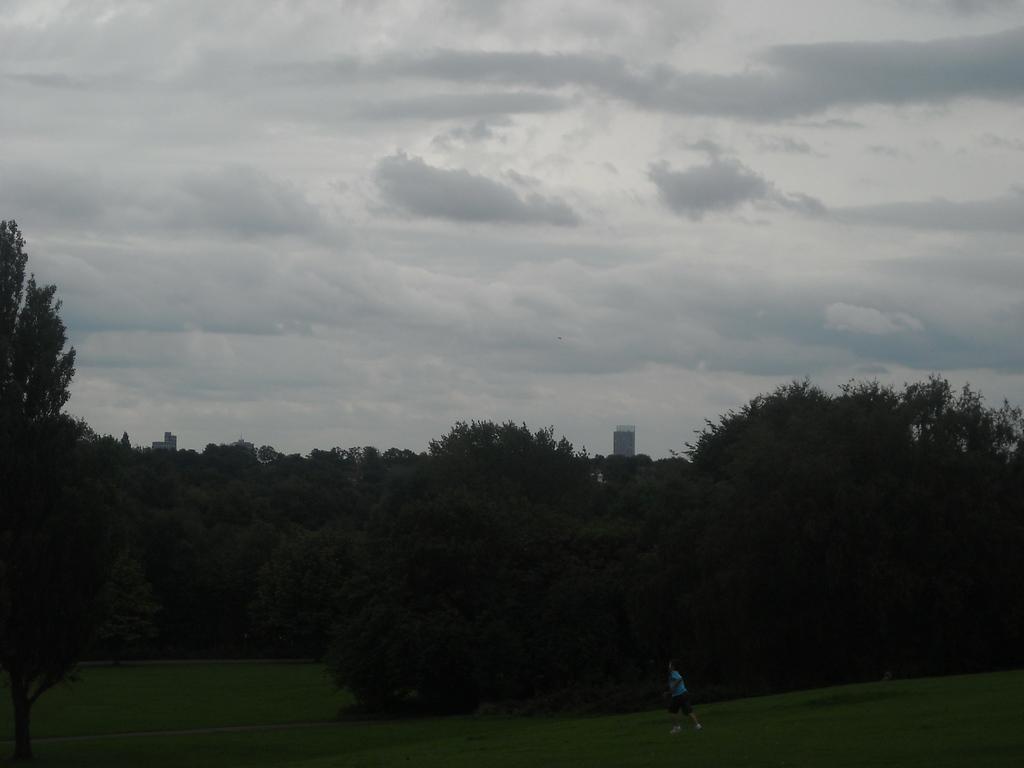Describe this image in one or two sentences. In this picture we can see a person is running on the grass path and behind the person there are trees and a cloudy sky. 